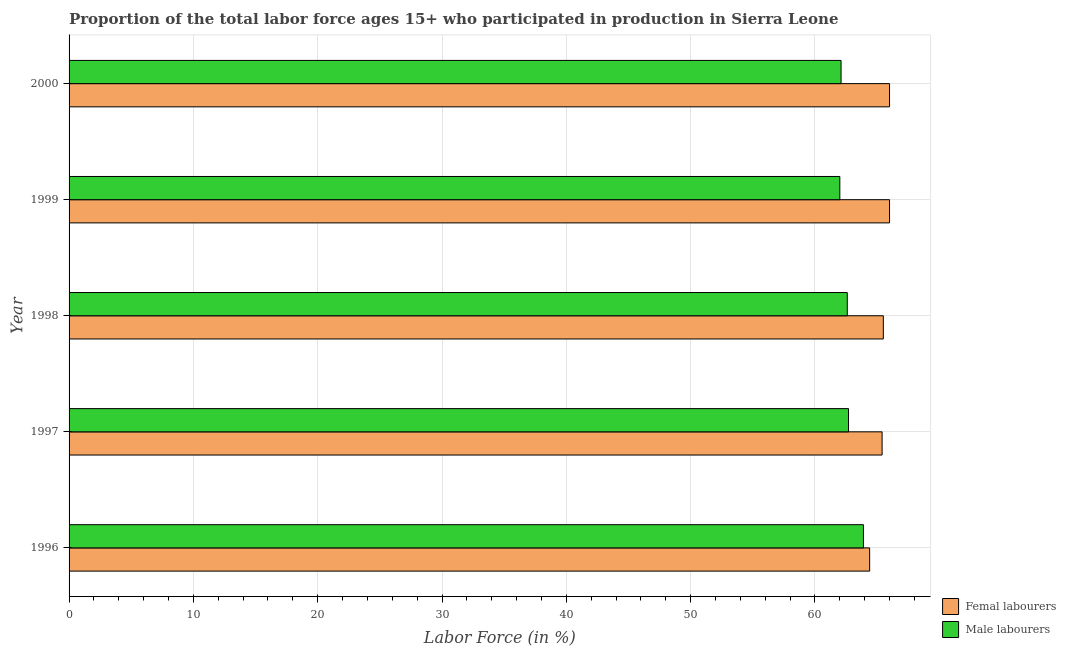How many different coloured bars are there?
Provide a short and direct response. 2. How many groups of bars are there?
Offer a very short reply. 5. Are the number of bars per tick equal to the number of legend labels?
Your answer should be very brief. Yes. How many bars are there on the 2nd tick from the top?
Provide a succinct answer. 2. How many bars are there on the 5th tick from the bottom?
Your answer should be very brief. 2. What is the label of the 4th group of bars from the top?
Ensure brevity in your answer.  1997. In how many cases, is the number of bars for a given year not equal to the number of legend labels?
Ensure brevity in your answer.  0. What is the percentage of female labor force in 1997?
Keep it short and to the point. 65.4. In which year was the percentage of male labour force minimum?
Offer a very short reply. 1999. What is the total percentage of male labour force in the graph?
Ensure brevity in your answer.  313.3. What is the difference between the percentage of female labor force in 1996 and that in 1998?
Give a very brief answer. -1.1. What is the difference between the percentage of female labor force in 1996 and the percentage of male labour force in 1997?
Provide a succinct answer. 1.7. What is the average percentage of male labour force per year?
Provide a succinct answer. 62.66. In how many years, is the percentage of female labor force greater than 6 %?
Offer a terse response. 5. Is the sum of the percentage of female labor force in 1997 and 1998 greater than the maximum percentage of male labour force across all years?
Offer a terse response. Yes. What does the 2nd bar from the top in 1998 represents?
Provide a short and direct response. Femal labourers. What does the 2nd bar from the bottom in 1999 represents?
Ensure brevity in your answer.  Male labourers. Are all the bars in the graph horizontal?
Your answer should be compact. Yes. How many years are there in the graph?
Provide a short and direct response. 5. Are the values on the major ticks of X-axis written in scientific E-notation?
Your response must be concise. No. Does the graph contain any zero values?
Your answer should be very brief. No. Does the graph contain grids?
Make the answer very short. Yes. Where does the legend appear in the graph?
Give a very brief answer. Bottom right. What is the title of the graph?
Provide a short and direct response. Proportion of the total labor force ages 15+ who participated in production in Sierra Leone. What is the label or title of the X-axis?
Offer a terse response. Labor Force (in %). What is the Labor Force (in %) of Femal labourers in 1996?
Offer a very short reply. 64.4. What is the Labor Force (in %) in Male labourers in 1996?
Provide a succinct answer. 63.9. What is the Labor Force (in %) in Femal labourers in 1997?
Ensure brevity in your answer.  65.4. What is the Labor Force (in %) in Male labourers in 1997?
Give a very brief answer. 62.7. What is the Labor Force (in %) in Femal labourers in 1998?
Give a very brief answer. 65.5. What is the Labor Force (in %) of Male labourers in 1998?
Provide a succinct answer. 62.6. What is the Labor Force (in %) of Femal labourers in 1999?
Your answer should be very brief. 66. What is the Labor Force (in %) of Femal labourers in 2000?
Your response must be concise. 66. What is the Labor Force (in %) of Male labourers in 2000?
Your answer should be very brief. 62.1. Across all years, what is the maximum Labor Force (in %) of Femal labourers?
Provide a short and direct response. 66. Across all years, what is the maximum Labor Force (in %) of Male labourers?
Your response must be concise. 63.9. Across all years, what is the minimum Labor Force (in %) in Femal labourers?
Keep it short and to the point. 64.4. What is the total Labor Force (in %) in Femal labourers in the graph?
Your answer should be compact. 327.3. What is the total Labor Force (in %) of Male labourers in the graph?
Provide a short and direct response. 313.3. What is the difference between the Labor Force (in %) of Male labourers in 1996 and that in 1997?
Offer a very short reply. 1.2. What is the difference between the Labor Force (in %) of Femal labourers in 1996 and that in 1998?
Ensure brevity in your answer.  -1.1. What is the difference between the Labor Force (in %) of Femal labourers in 1996 and that in 1999?
Ensure brevity in your answer.  -1.6. What is the difference between the Labor Force (in %) in Male labourers in 1996 and that in 1999?
Your answer should be very brief. 1.9. What is the difference between the Labor Force (in %) in Male labourers in 1997 and that in 1998?
Offer a very short reply. 0.1. What is the difference between the Labor Force (in %) in Femal labourers in 1997 and that in 1999?
Your answer should be very brief. -0.6. What is the difference between the Labor Force (in %) of Male labourers in 1998 and that in 2000?
Your response must be concise. 0.5. What is the difference between the Labor Force (in %) of Femal labourers in 1999 and that in 2000?
Make the answer very short. 0. What is the difference between the Labor Force (in %) of Femal labourers in 1996 and the Labor Force (in %) of Male labourers in 1997?
Your answer should be very brief. 1.7. What is the difference between the Labor Force (in %) in Femal labourers in 1996 and the Labor Force (in %) in Male labourers in 1998?
Your answer should be very brief. 1.8. What is the difference between the Labor Force (in %) of Femal labourers in 1996 and the Labor Force (in %) of Male labourers in 2000?
Provide a short and direct response. 2.3. What is the difference between the Labor Force (in %) in Femal labourers in 1998 and the Labor Force (in %) in Male labourers in 2000?
Your response must be concise. 3.4. What is the average Labor Force (in %) in Femal labourers per year?
Your answer should be very brief. 65.46. What is the average Labor Force (in %) in Male labourers per year?
Give a very brief answer. 62.66. In the year 1997, what is the difference between the Labor Force (in %) of Femal labourers and Labor Force (in %) of Male labourers?
Offer a terse response. 2.7. In the year 1998, what is the difference between the Labor Force (in %) in Femal labourers and Labor Force (in %) in Male labourers?
Your response must be concise. 2.9. In the year 1999, what is the difference between the Labor Force (in %) in Femal labourers and Labor Force (in %) in Male labourers?
Your answer should be compact. 4. In the year 2000, what is the difference between the Labor Force (in %) of Femal labourers and Labor Force (in %) of Male labourers?
Provide a short and direct response. 3.9. What is the ratio of the Labor Force (in %) of Femal labourers in 1996 to that in 1997?
Provide a succinct answer. 0.98. What is the ratio of the Labor Force (in %) in Male labourers in 1996 to that in 1997?
Your answer should be compact. 1.02. What is the ratio of the Labor Force (in %) of Femal labourers in 1996 to that in 1998?
Ensure brevity in your answer.  0.98. What is the ratio of the Labor Force (in %) of Male labourers in 1996 to that in 1998?
Give a very brief answer. 1.02. What is the ratio of the Labor Force (in %) of Femal labourers in 1996 to that in 1999?
Provide a succinct answer. 0.98. What is the ratio of the Labor Force (in %) of Male labourers in 1996 to that in 1999?
Provide a short and direct response. 1.03. What is the ratio of the Labor Force (in %) in Femal labourers in 1996 to that in 2000?
Ensure brevity in your answer.  0.98. What is the ratio of the Labor Force (in %) in Male labourers in 1996 to that in 2000?
Your answer should be very brief. 1.03. What is the ratio of the Labor Force (in %) in Male labourers in 1997 to that in 1998?
Provide a short and direct response. 1. What is the ratio of the Labor Force (in %) of Femal labourers in 1997 to that in 1999?
Offer a very short reply. 0.99. What is the ratio of the Labor Force (in %) in Male labourers in 1997 to that in 1999?
Keep it short and to the point. 1.01. What is the ratio of the Labor Force (in %) of Femal labourers in 1997 to that in 2000?
Your response must be concise. 0.99. What is the ratio of the Labor Force (in %) of Male labourers in 1997 to that in 2000?
Your response must be concise. 1.01. What is the ratio of the Labor Force (in %) in Male labourers in 1998 to that in 1999?
Ensure brevity in your answer.  1.01. What is the difference between the highest and the second highest Labor Force (in %) in Femal labourers?
Give a very brief answer. 0. What is the difference between the highest and the second highest Labor Force (in %) in Male labourers?
Provide a short and direct response. 1.2. What is the difference between the highest and the lowest Labor Force (in %) of Femal labourers?
Ensure brevity in your answer.  1.6. 